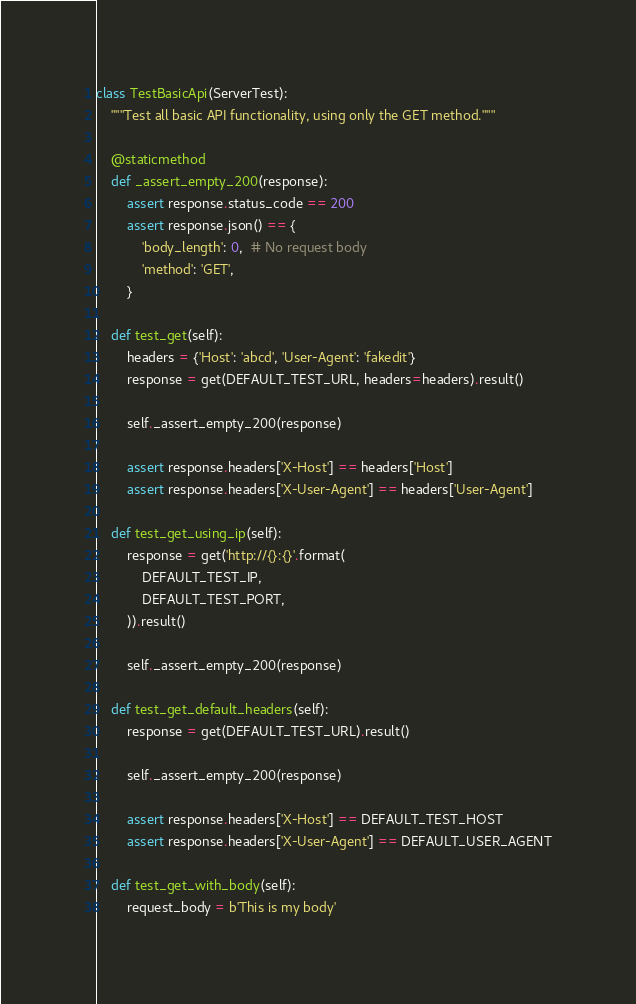<code> <loc_0><loc_0><loc_500><loc_500><_Python_>class TestBasicApi(ServerTest):
    """Test all basic API functionality, using only the GET method."""

    @staticmethod
    def _assert_empty_200(response):
        assert response.status_code == 200
        assert response.json() == {
            'body_length': 0,  # No request body
            'method': 'GET',
        }

    def test_get(self):
        headers = {'Host': 'abcd', 'User-Agent': 'fakedit'}
        response = get(DEFAULT_TEST_URL, headers=headers).result()

        self._assert_empty_200(response)

        assert response.headers['X-Host'] == headers['Host']
        assert response.headers['X-User-Agent'] == headers['User-Agent']

    def test_get_using_ip(self):
        response = get('http://{}:{}'.format(
            DEFAULT_TEST_IP,
            DEFAULT_TEST_PORT,
        )).result()

        self._assert_empty_200(response)

    def test_get_default_headers(self):
        response = get(DEFAULT_TEST_URL).result()

        self._assert_empty_200(response)

        assert response.headers['X-Host'] == DEFAULT_TEST_HOST
        assert response.headers['X-User-Agent'] == DEFAULT_USER_AGENT

    def test_get_with_body(self):
        request_body = b'This is my body'</code> 